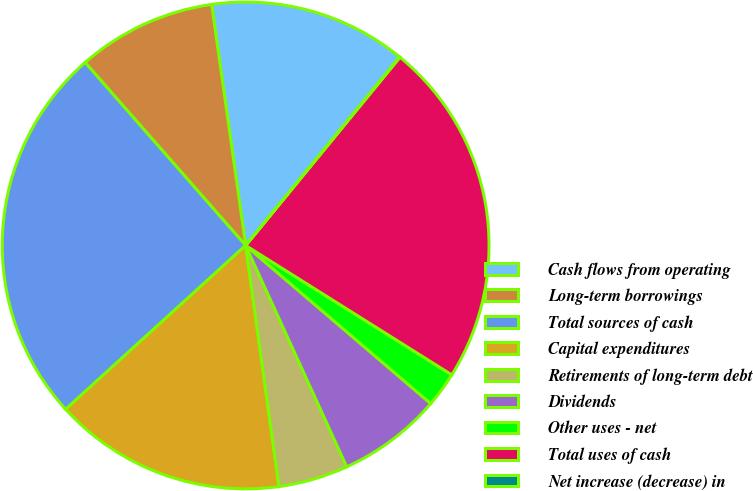Convert chart. <chart><loc_0><loc_0><loc_500><loc_500><pie_chart><fcel>Cash flows from operating<fcel>Long-term borrowings<fcel>Total sources of cash<fcel>Capital expenditures<fcel>Retirements of long-term debt<fcel>Dividends<fcel>Other uses - net<fcel>Total uses of cash<fcel>Net increase (decrease) in<nl><fcel>13.13%<fcel>9.23%<fcel>25.29%<fcel>15.43%<fcel>4.63%<fcel>6.93%<fcel>2.33%<fcel>22.99%<fcel>0.03%<nl></chart> 